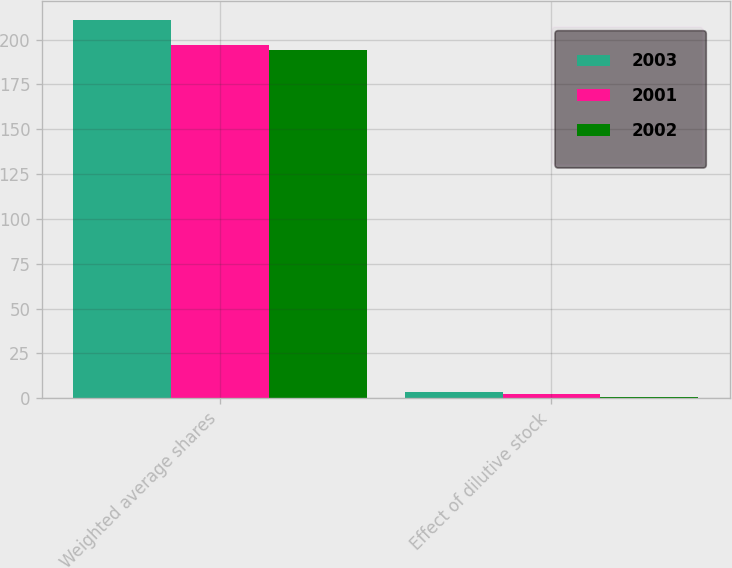Convert chart. <chart><loc_0><loc_0><loc_500><loc_500><stacked_bar_chart><ecel><fcel>Weighted average shares<fcel>Effect of dilutive stock<nl><fcel>2003<fcel>211.2<fcel>3.5<nl><fcel>2001<fcel>196.8<fcel>2.3<nl><fcel>2002<fcel>194.3<fcel>0.6<nl></chart> 